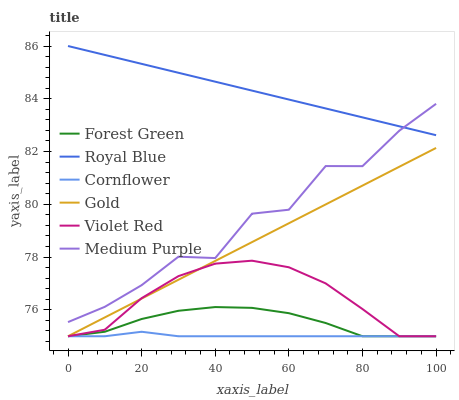Does Violet Red have the minimum area under the curve?
Answer yes or no. No. Does Violet Red have the maximum area under the curve?
Answer yes or no. No. Is Violet Red the smoothest?
Answer yes or no. No. Is Violet Red the roughest?
Answer yes or no. No. Does Medium Purple have the lowest value?
Answer yes or no. No. Does Violet Red have the highest value?
Answer yes or no. No. Is Gold less than Medium Purple?
Answer yes or no. Yes. Is Medium Purple greater than Forest Green?
Answer yes or no. Yes. Does Gold intersect Medium Purple?
Answer yes or no. No. 